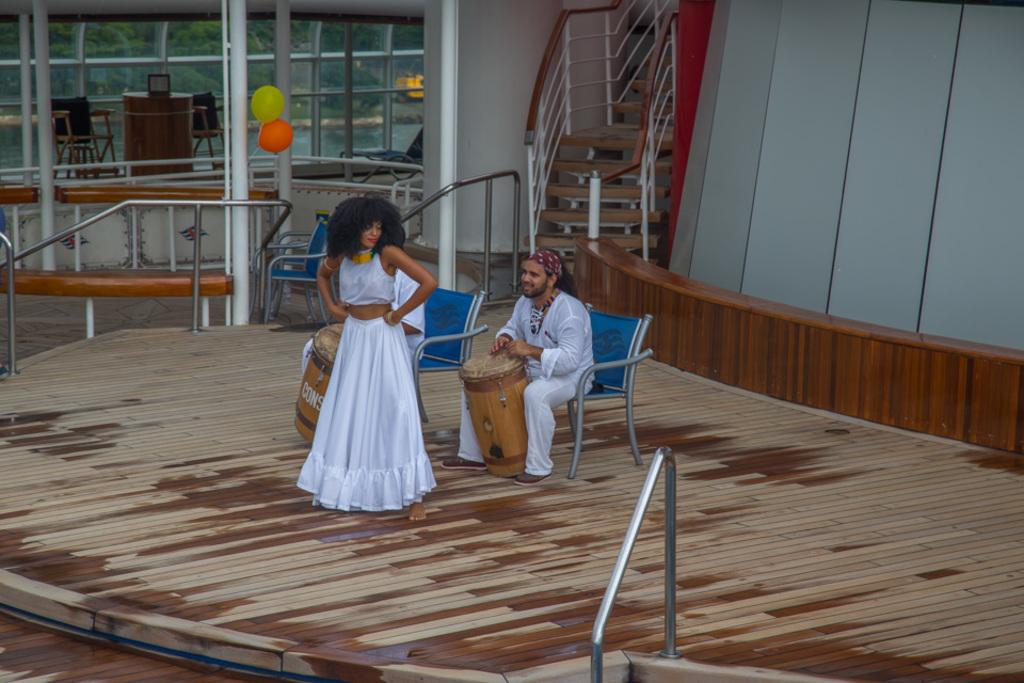How many people are in the image? There are two people in the image, a man and a woman. What is the man doing in the image? The man is sitting on a chair and playing a musical instrument. What can be seen in the background of the image? There is a staircase, a window, balloons, a table, and a chair in the background of the image. What type of jeans is the ocean wearing in the image? There is no ocean or jeans present in the image. Can you tell me how many pockets are on the pocket in the image? There is no pocket present in the image. 